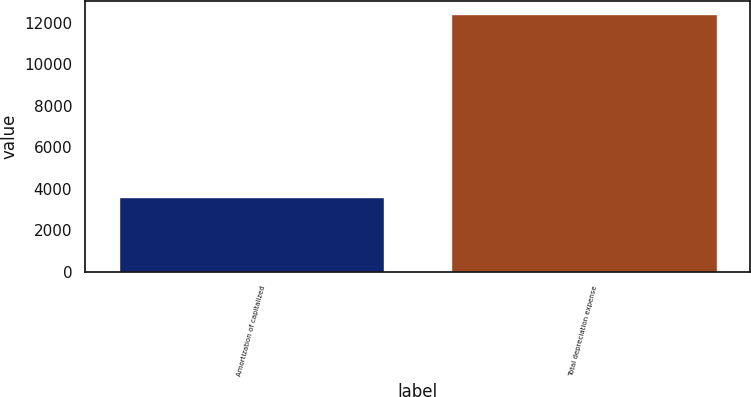<chart> <loc_0><loc_0><loc_500><loc_500><bar_chart><fcel>Amortization of capitalized<fcel>Total depreciation expense<nl><fcel>3600<fcel>12434<nl></chart> 